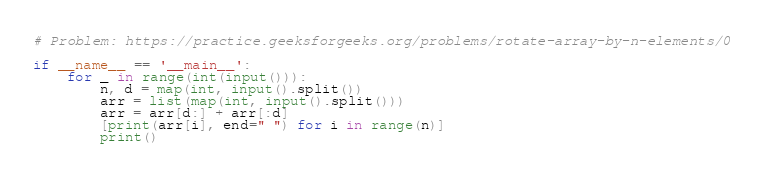<code> <loc_0><loc_0><loc_500><loc_500><_Python_># Problem: https://practice.geeksforgeeks.org/problems/rotate-array-by-n-elements/0

if __name__ == '__main__':
    for _ in range(int(input())):
        n, d = map(int, input().split())
        arr = list(map(int, input().split()))
        arr = arr[d:] + arr[:d]
        [print(arr[i], end=" ") for i in range(n)]
        print()
</code> 